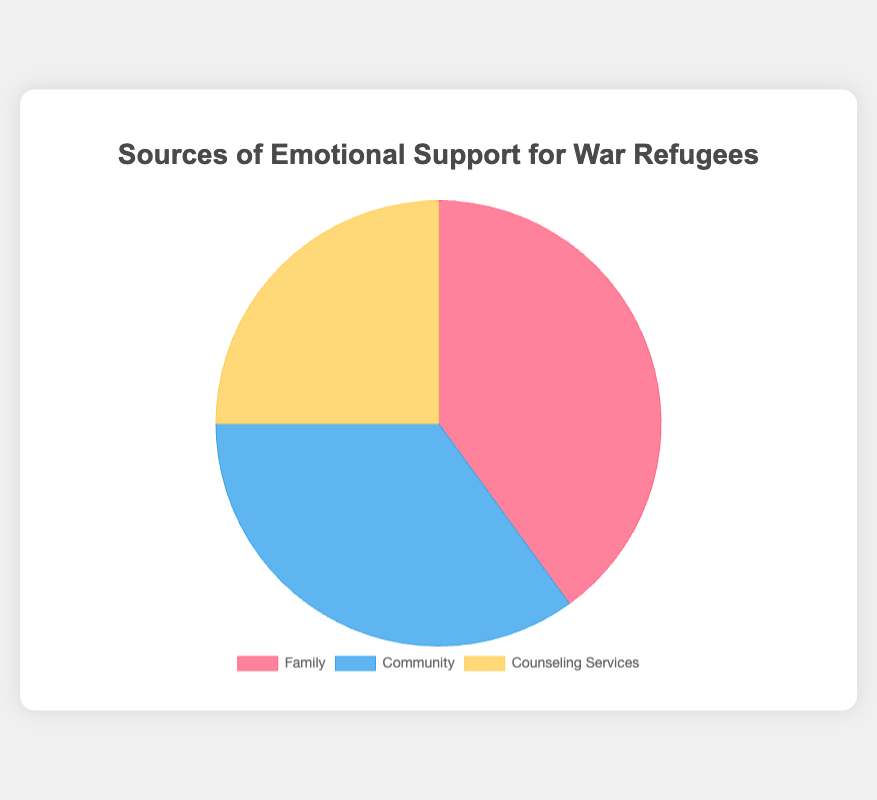What's the largest source of emotional support for war refugees? The pie chart shows three sources of emotional support: Family, Community, and Counseling Services. By looking at the percentages, Family has the highest value at 40%.
Answer: Family Which source of emotional support provides support almost equally to both Immediate Family and Extended Family? The detailed data shows that within the Family category, Immediate Family accounts for 25% and Extended Family accounts for 15%. These two combined give the total for family support.
Answer: Family How many percentages more do Family and Community combined provide compared to Counseling Services? Family (40%) and Community (35%) combined provide a total of 75%. Counseling Services provide 25%. Therefore, the difference is 75% - 25% = 50%.
Answer: 50% Which source of emotional support provides the least support overall? The pie chart shows three sources of support with their percentages. Counseling Services has the lowest percentage at 25%.
Answer: Counseling Services How much bigger is the support from the Local Refugee Organizations compared to Volunteer Groups within the Community support source? Within the Community support source, Local Refugee Organizations provide 20%, and Volunteer Groups provide 5%. The difference is 20% - 5% = 15%.
Answer: 15% What is the combined percentage of support provided by Professional Counselors and Extended Family? Professional Counselors provide 10%, and Extended Family provides 15%. Their combined percentage is 10% + 15% = 25%.
Answer: 25% Is the support given by Community more than both Immediate Family and Extended Family combined? Immediate Family provides 25%, and Extended Family provides 15%. Together, they provide 40%. The Community provides 35%. By comparing these values, 40% (Family) is greater than 35% (Community).
Answer: No Which has a larger visual representation in the pie chart, Family support or Community support? In the pie chart, Family support is represented with a larger slice compared to Community support. Family has 40%, while Community has 35%.
Answer: Family What percentage of support comes from sources other than Family? Family provides 40%. The total support is 100%. Therefore, support from sources other than Family is 100% - 40% = 60%.
Answer: 60% 